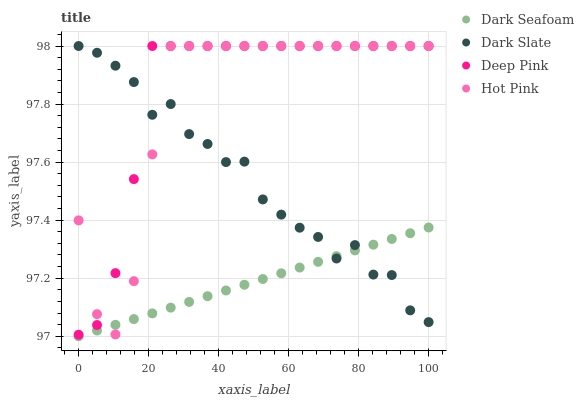Does Dark Seafoam have the minimum area under the curve?
Answer yes or no. Yes. Does Deep Pink have the maximum area under the curve?
Answer yes or no. Yes. Does Deep Pink have the minimum area under the curve?
Answer yes or no. No. Does Dark Seafoam have the maximum area under the curve?
Answer yes or no. No. Is Dark Seafoam the smoothest?
Answer yes or no. Yes. Is Dark Slate the roughest?
Answer yes or no. Yes. Is Deep Pink the smoothest?
Answer yes or no. No. Is Deep Pink the roughest?
Answer yes or no. No. Does Dark Seafoam have the lowest value?
Answer yes or no. Yes. Does Deep Pink have the lowest value?
Answer yes or no. No. Does Hot Pink have the highest value?
Answer yes or no. Yes. Does Dark Seafoam have the highest value?
Answer yes or no. No. Is Dark Seafoam less than Deep Pink?
Answer yes or no. Yes. Is Deep Pink greater than Dark Seafoam?
Answer yes or no. Yes. Does Deep Pink intersect Dark Slate?
Answer yes or no. Yes. Is Deep Pink less than Dark Slate?
Answer yes or no. No. Is Deep Pink greater than Dark Slate?
Answer yes or no. No. Does Dark Seafoam intersect Deep Pink?
Answer yes or no. No. 